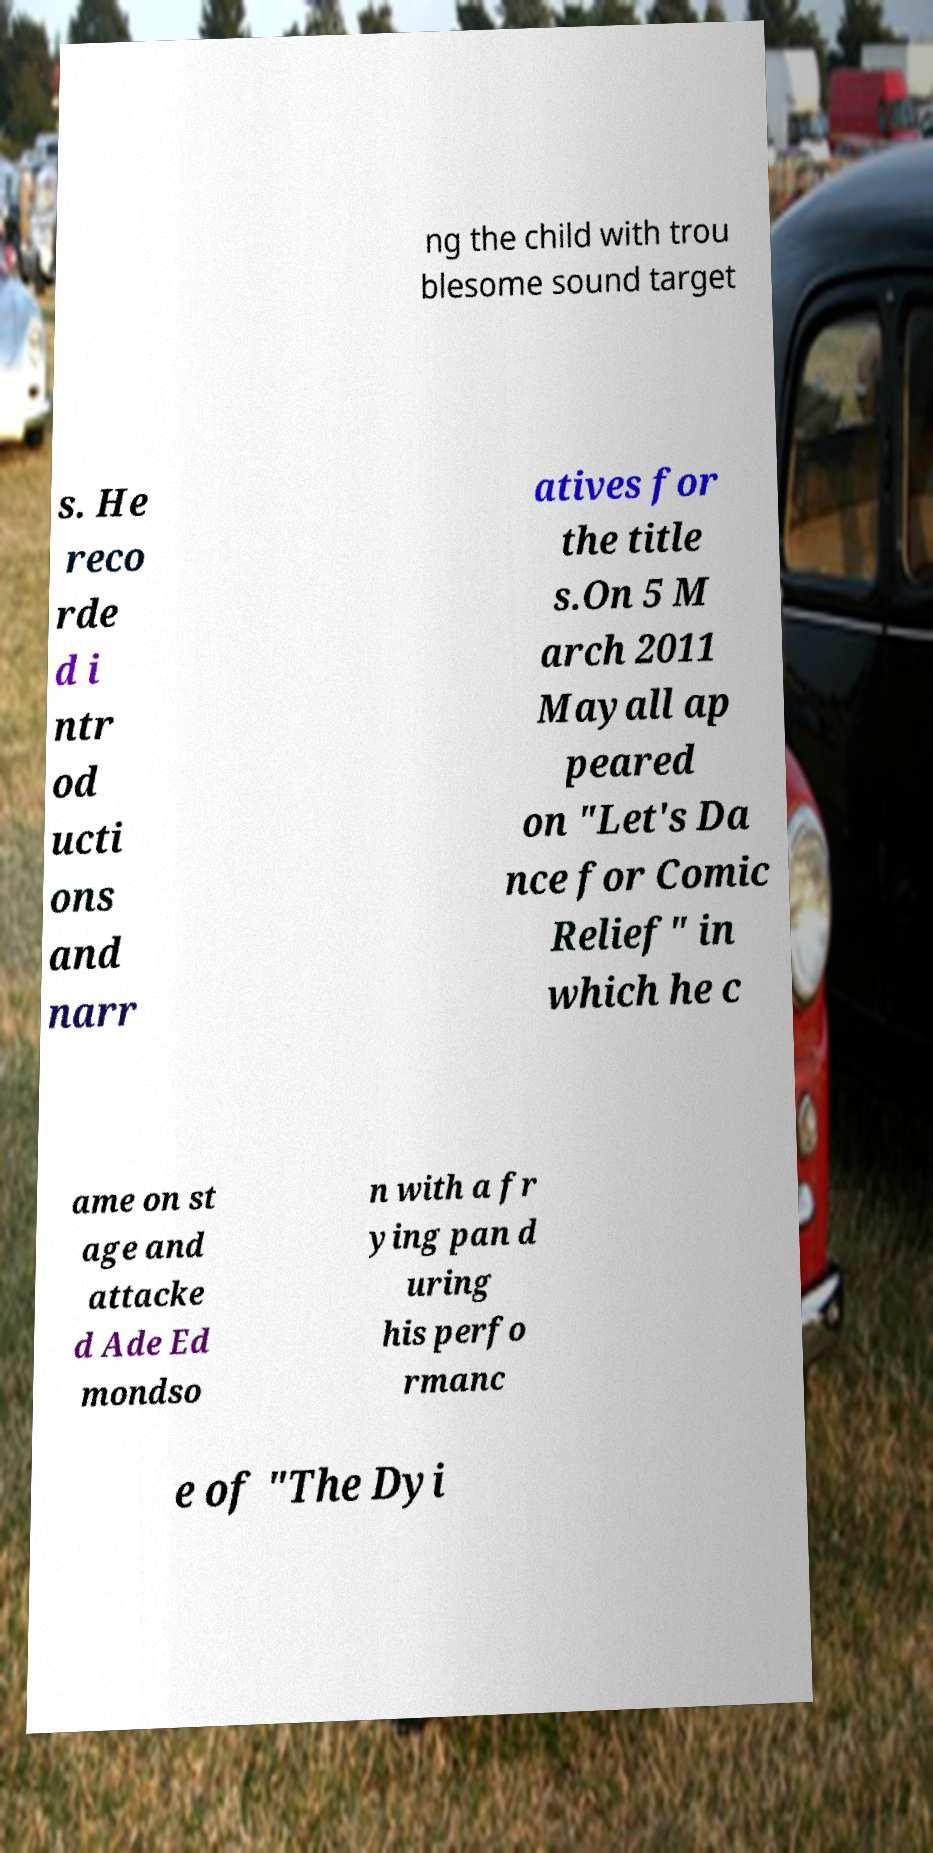For documentation purposes, I need the text within this image transcribed. Could you provide that? ng the child with trou blesome sound target s. He reco rde d i ntr od ucti ons and narr atives for the title s.On 5 M arch 2011 Mayall ap peared on "Let's Da nce for Comic Relief" in which he c ame on st age and attacke d Ade Ed mondso n with a fr ying pan d uring his perfo rmanc e of "The Dyi 